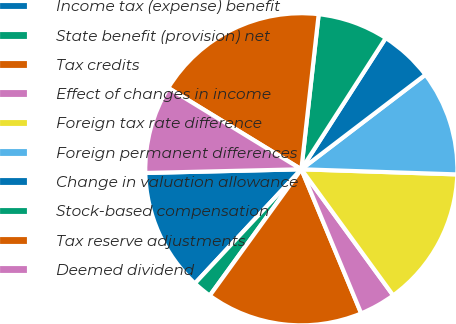Convert chart to OTSL. <chart><loc_0><loc_0><loc_500><loc_500><pie_chart><fcel>Income tax (expense) benefit<fcel>State benefit (provision) net<fcel>Tax credits<fcel>Effect of changes in income<fcel>Foreign tax rate difference<fcel>Foreign permanent differences<fcel>Change in valuation allowance<fcel>Stock-based compensation<fcel>Tax reserve adjustments<fcel>Deemed dividend<nl><fcel>12.68%<fcel>1.96%<fcel>16.25%<fcel>3.75%<fcel>14.46%<fcel>10.89%<fcel>5.54%<fcel>7.32%<fcel>18.04%<fcel>9.11%<nl></chart> 